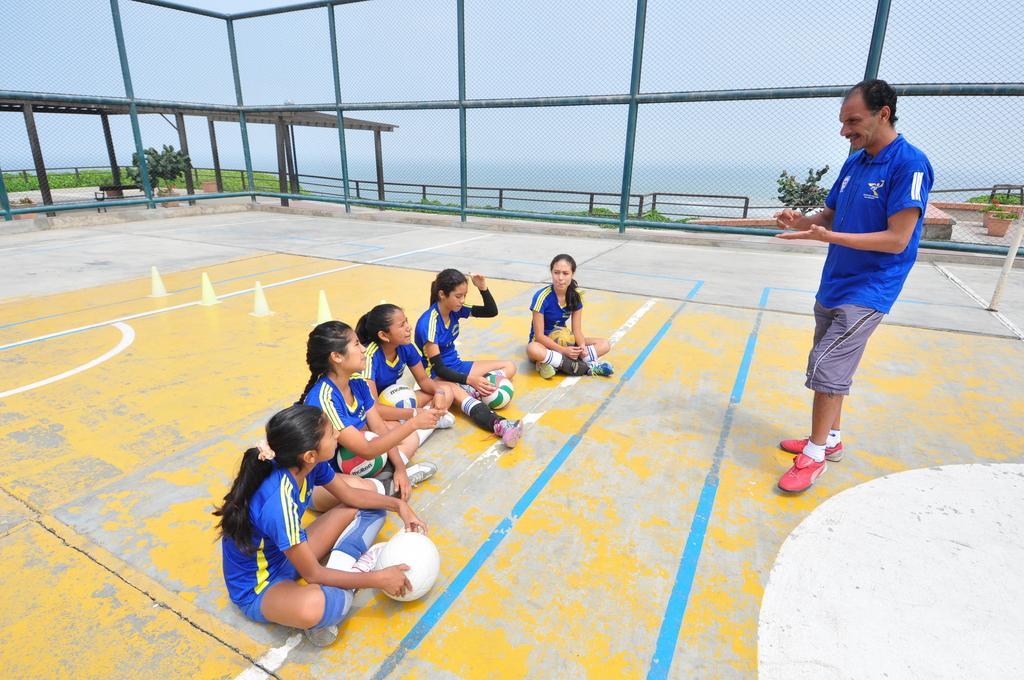In one or two sentences, can you explain what this image depicts? In the picture we can see a football court, in the court there are girls and a man. In the middle of the picture there are plants, construction and a water body. At the top there is sky. In the middle we can see railing also. 